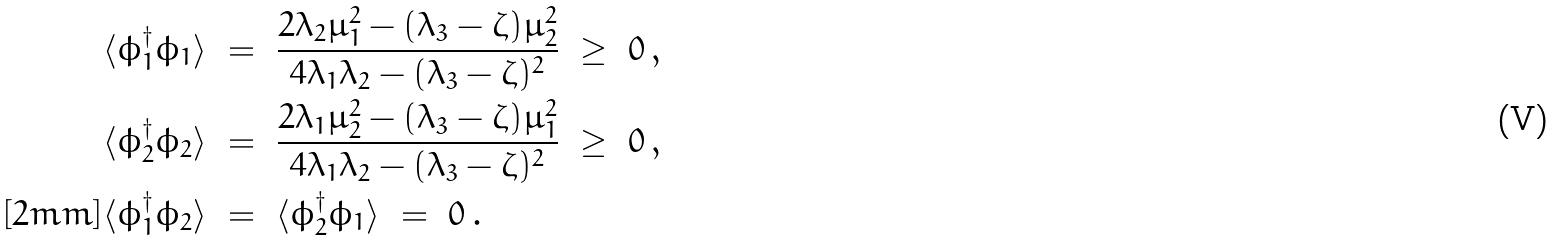Convert formula to latex. <formula><loc_0><loc_0><loc_500><loc_500>\langle \phi _ { 1 } ^ { \dagger } \phi _ { 1 } \rangle \ & = \ \frac { 2 \lambda _ { 2 } \mu _ { 1 } ^ { 2 } - ( \lambda _ { 3 } - \zeta ) \mu _ { 2 } ^ { 2 } } { 4 \lambda _ { 1 } \lambda _ { 2 } - ( \lambda _ { 3 } - \zeta ) ^ { 2 } } \ \geq \ 0 \, , \\ \langle \phi _ { 2 } ^ { \dagger } \phi _ { 2 } \rangle \ & = \ \frac { 2 \lambda _ { 1 } \mu _ { 2 } ^ { 2 } - ( \lambda _ { 3 } - \zeta ) \mu _ { 1 } ^ { 2 } } { 4 \lambda _ { 1 } \lambda _ { 2 } - ( \lambda _ { 3 } - \zeta ) ^ { 2 } } \ \geq \ 0 \, , \\ [ 2 m m ] \langle \phi _ { 1 } ^ { \dagger } \phi _ { 2 } \rangle \ & = \ \langle \phi _ { 2 } ^ { \dagger } \phi _ { 1 } \rangle \ = \ 0 \, .</formula> 